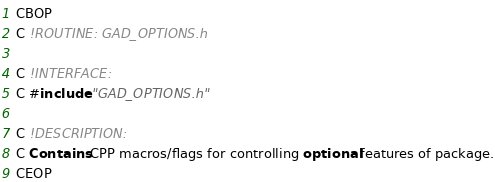Convert code to text. <code><loc_0><loc_0><loc_500><loc_500><_FORTRAN_>












CBOP
C !ROUTINE: GAD_OPTIONS.h

C !INTERFACE:
C #include "GAD_OPTIONS.h"

C !DESCRIPTION:
C Contains CPP macros/flags for controlling optional features of package.
CEOP
</code> 